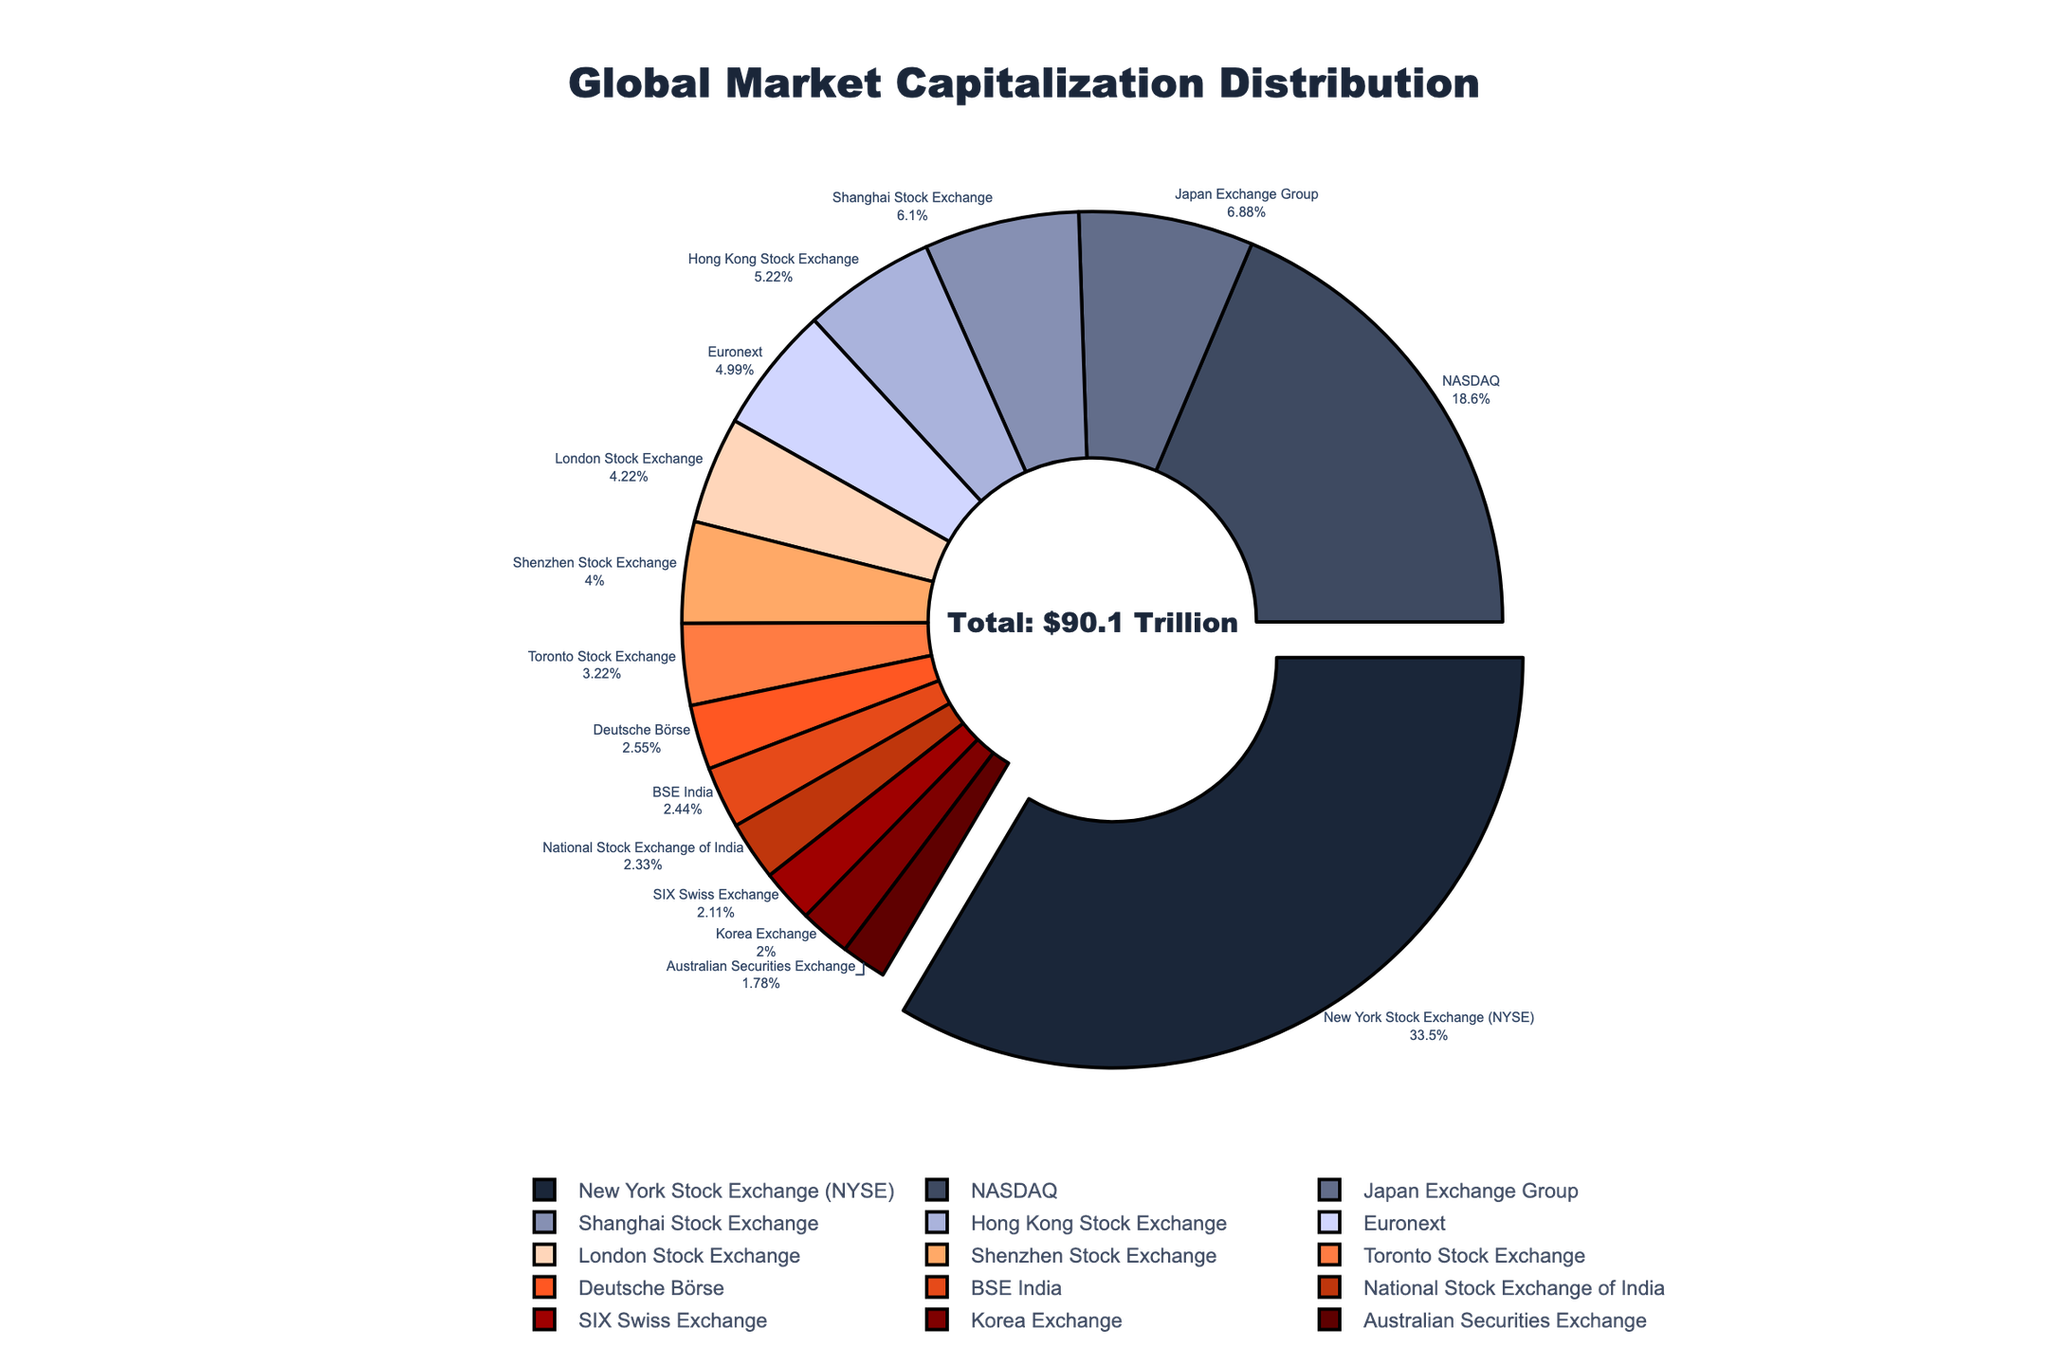What percentage of the total global market capitalization is represented by the New York Stock Exchange (NYSE)? The NYSE market cap is $30.2 trillion out of a total approximately $90.1 trillion. The percentage is calculated as (30.2 / 90.1) * 100 ≈ 33.5%.
Answer: 33.5% Which exchange has the second-largest market capitalization and what is its percentage of the total market cap? The second-largest market cap is NASDAQ at $16.8 trillion. The percentage is (16.8 / 90.1) * 100 ≈ 18.6%.
Answer: NASDAQ, 18.6% Compare the market capitalization of the Tokyo Stock Exchange to that of the Shanghai Stock Exchange. Which one is larger and by how much? The Tokyo Stock Exchange (Japan Exchange Group) has a market cap of $6.2 trillion, while the Shanghai Stock Exchange has $5.5 trillion. The difference is 6.2 - 5.5 = $0.7 trillion.
Answer: Tokyo, $0.7 trillion Sum the market capitalizations of the Hong Kong Stock Exchange and the Euronext and determine the percentage of the total market cap they together represent. The market caps are $4.7 trillion (Hong Kong) and $4.5 trillion (Euronext). Summed up, this is 4.7 + 4.5 = $9.2 trillion. The percentage is (9.2 / 90.1) * 100 ≈ 10.2%.
Answer: 10.2% What is the combined market capitalization of all exchanges with a market cap less than $5 trillion? The exchanges meeting this criteria and their market caps are listed: 
- Euronext $4.5 trillion 
- London $3.8 trillion 
- Shenzhen $3.6 trillion 
- Toronto $2.9 trillion 
- Deutsche Börse $2.3 trillion 
- BSE India $2.2 trillion 
- NSE India $2.1 trillion 
- SIX Swiss $1.9 trillion 
- Korea $1.8 trillion 
- Australian $1.6 trillion. 
Summing these up: $4.5 + $3.8 + $3.6 + $2.9 + $2.3 + $2.2 + $2.1 + $1.9 + $1.8 + $1.6 = $26.7 trillion.
Answer: $26.7 trillion Identify the stock exchange with the smallest share of the global market capitalization and its share as a percentage. The Australian Securities Exchange has the smallest market cap of $1.6 trillion. The percentage is (1.6 / 90.1) * 100 ≈ 1.8%.
Answer: Australian Securities Exchange, 1.8% Which exchange has the most distinct visual styling in the pie chart and what features highlight its uniqueness? The New York Stock Exchange (NYSE) has the distinct visual styling being slightly pulled out from the pie chart and positioned at the starting angle, making it stand out.
Answer: NYSE 